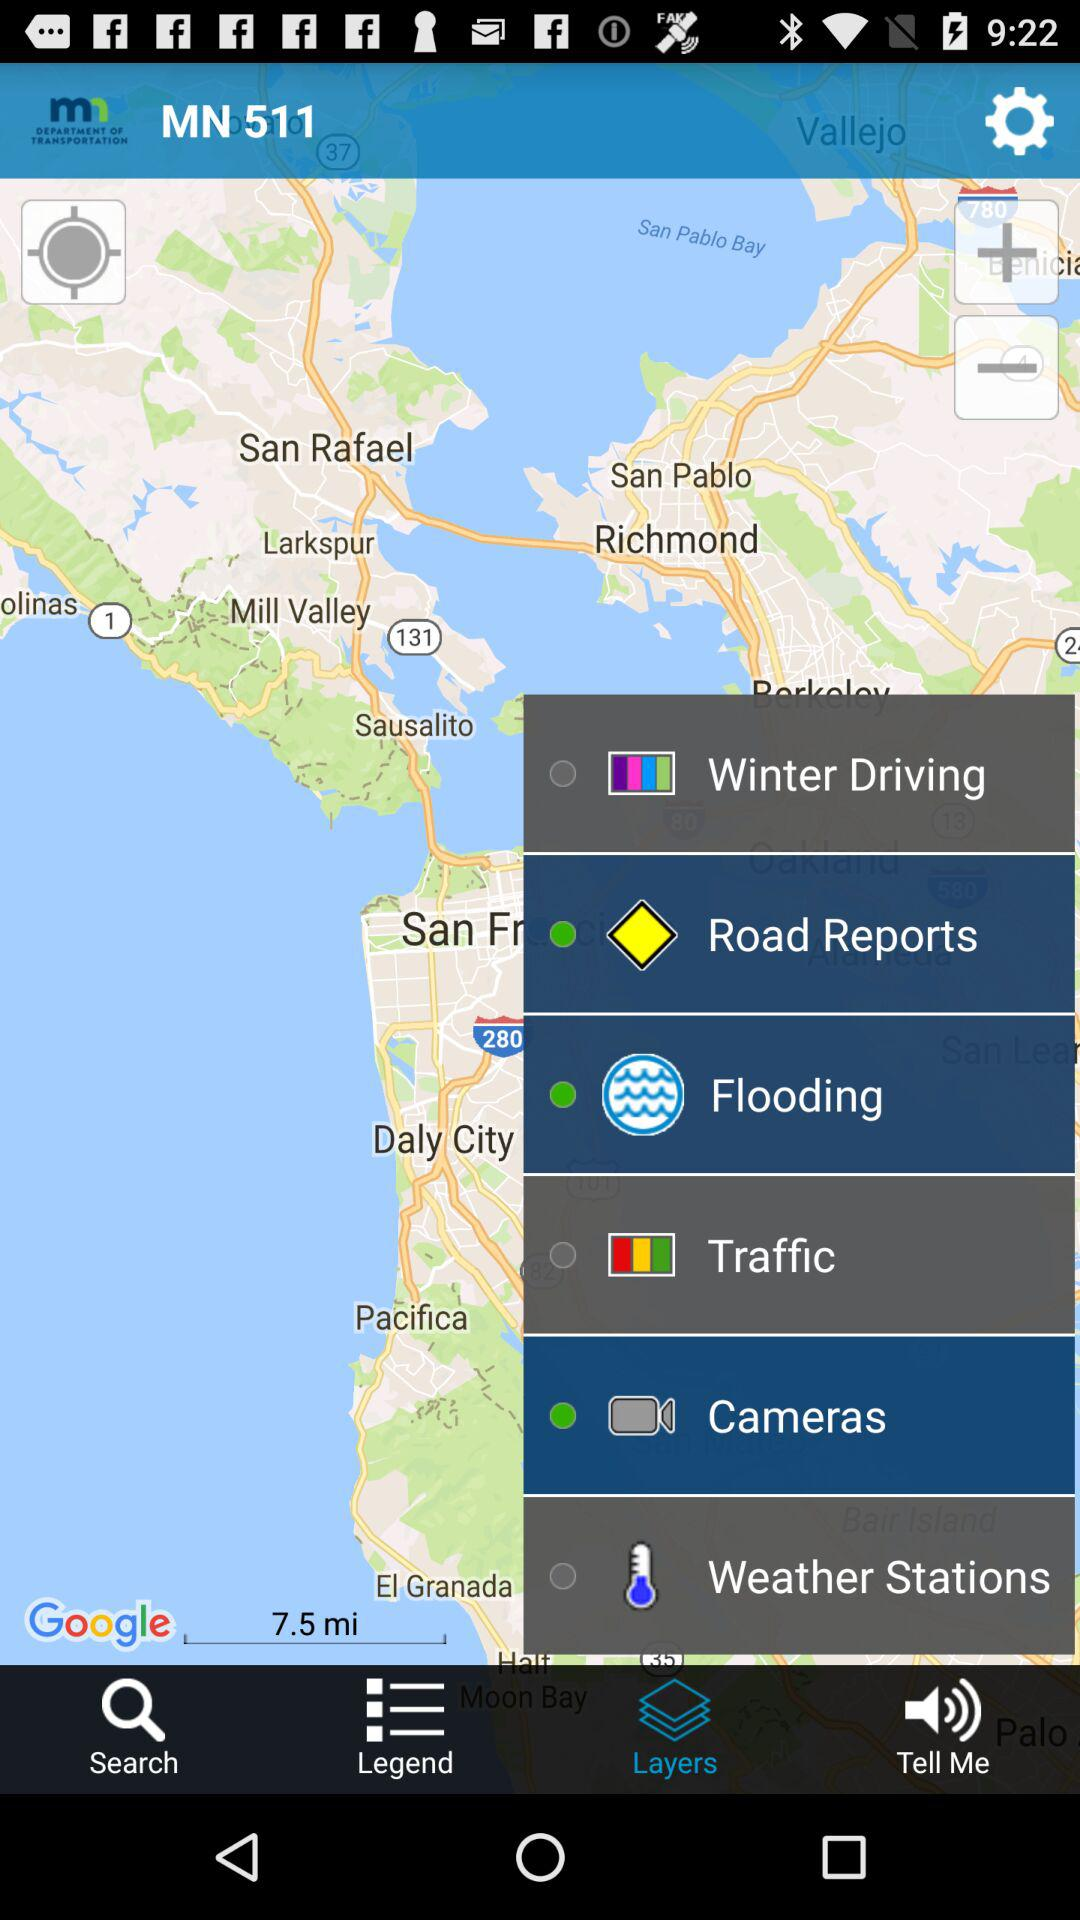Which tab has been selected? The tab that has been selected is "Layers". 